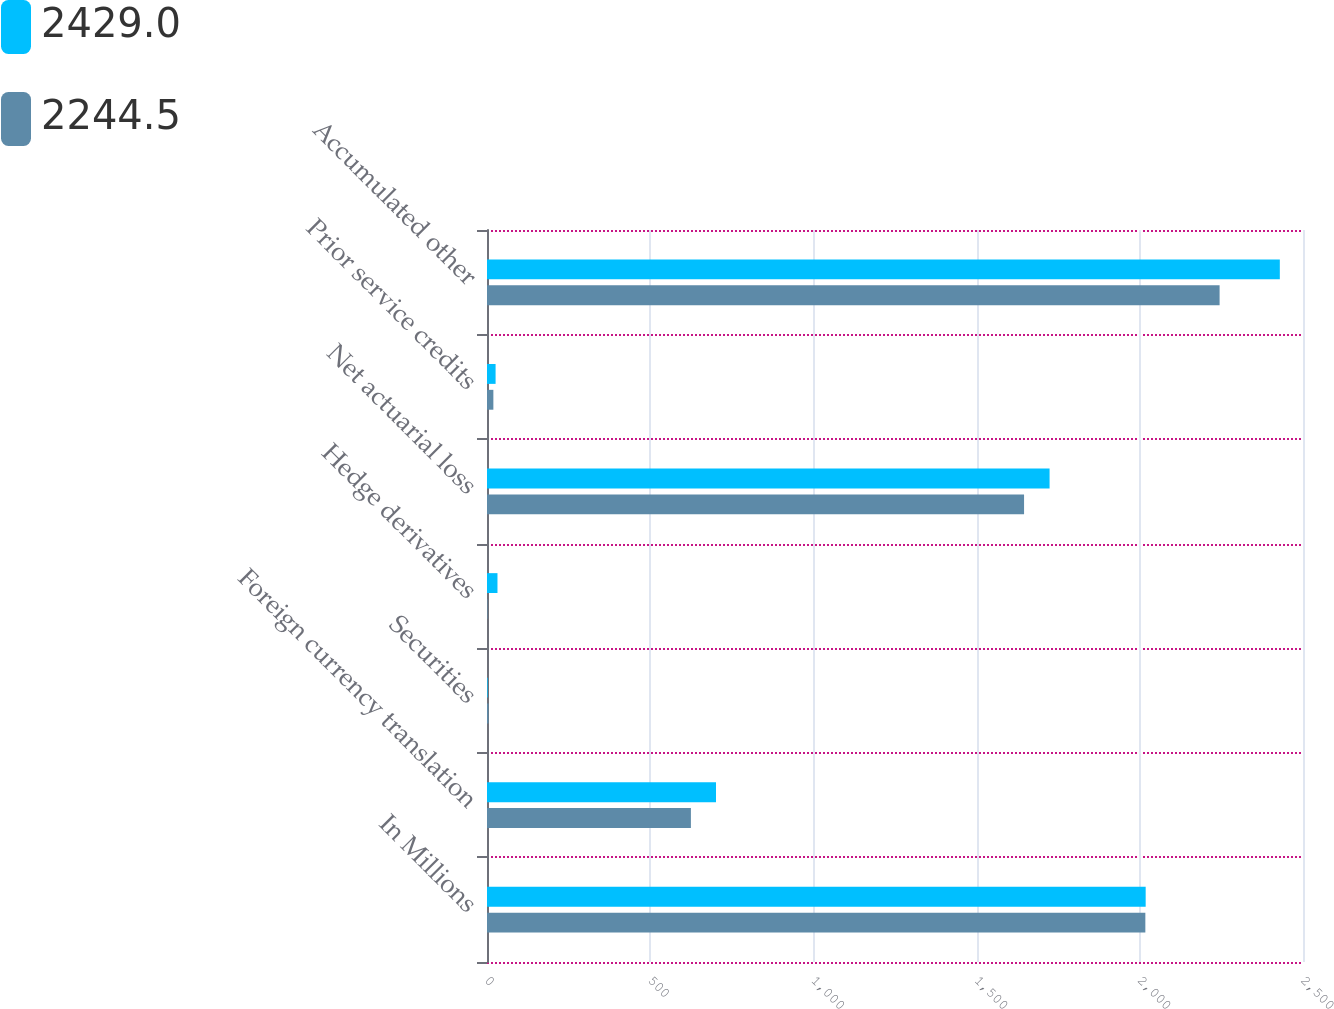Convert chart. <chart><loc_0><loc_0><loc_500><loc_500><stacked_bar_chart><ecel><fcel>In Millions<fcel>Foreign currency translation<fcel>Securities<fcel>Hedge derivatives<fcel>Net actuarial loss<fcel>Prior service credits<fcel>Accumulated other<nl><fcel>2429<fcel>2018<fcel>701.6<fcel>2<fcel>32.1<fcel>1723.6<fcel>26.3<fcel>2429<nl><fcel>2244.5<fcel>2017<fcel>624.7<fcel>4.6<fcel>1.5<fcel>1645.4<fcel>19.5<fcel>2244.5<nl></chart> 